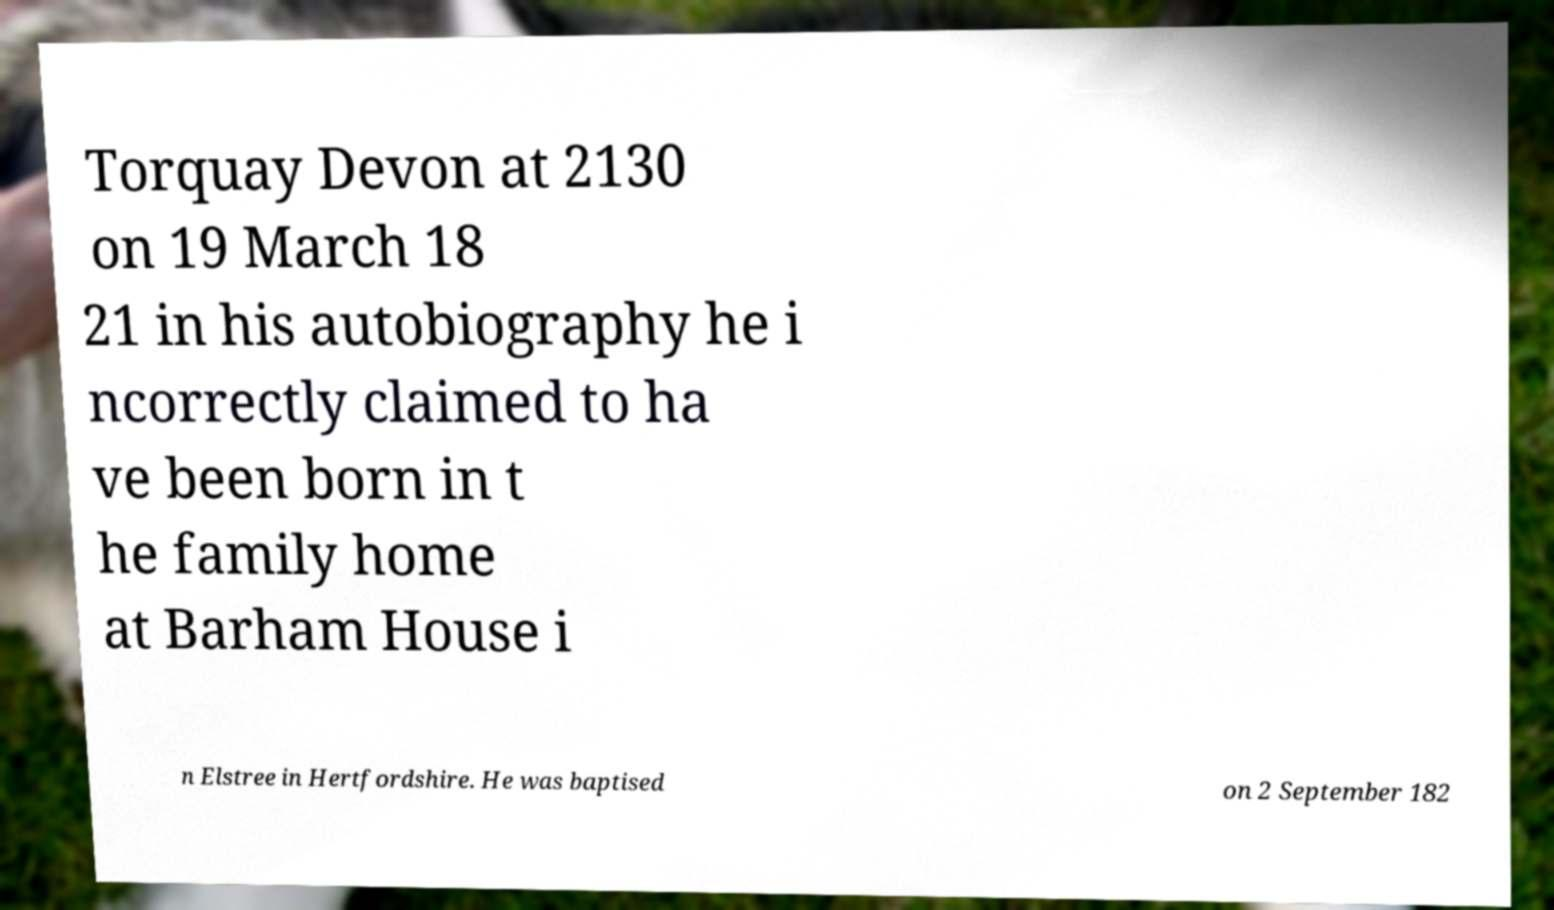For documentation purposes, I need the text within this image transcribed. Could you provide that? Torquay Devon at 2130 on 19 March 18 21 in his autobiography he i ncorrectly claimed to ha ve been born in t he family home at Barham House i n Elstree in Hertfordshire. He was baptised on 2 September 182 